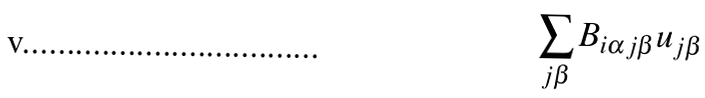<formula> <loc_0><loc_0><loc_500><loc_500>\sum _ { j \beta } B _ { i \alpha j \beta } u _ { j \beta }</formula> 